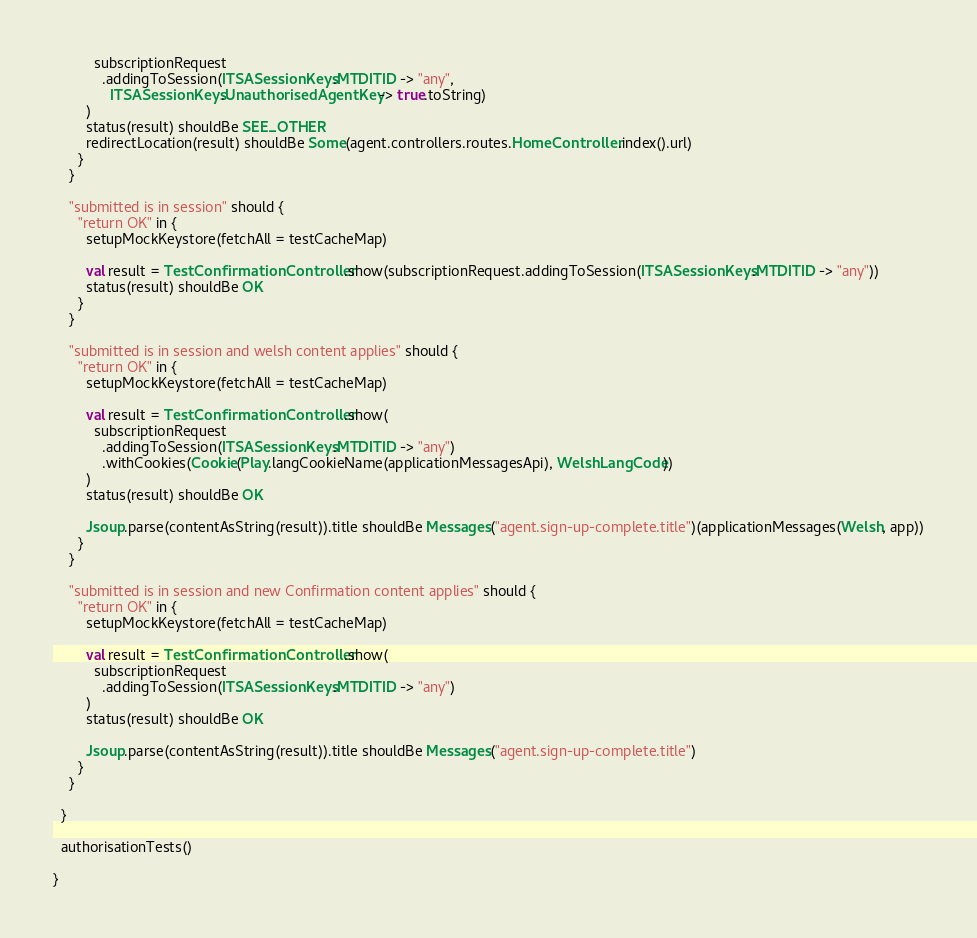<code> <loc_0><loc_0><loc_500><loc_500><_Scala_>          subscriptionRequest
            .addingToSession(ITSASessionKeys.MTDITID -> "any",
              ITSASessionKeys.UnauthorisedAgentKey -> true.toString)
        )
        status(result) shouldBe SEE_OTHER
        redirectLocation(result) shouldBe Some(agent.controllers.routes.HomeController.index().url)
      }
    }

    "submitted is in session" should {
      "return OK" in {
        setupMockKeystore(fetchAll = testCacheMap)

        val result = TestConfirmationController.show(subscriptionRequest.addingToSession(ITSASessionKeys.MTDITID -> "any"))
        status(result) shouldBe OK
      }
    }

    "submitted is in session and welsh content applies" should {
      "return OK" in {
        setupMockKeystore(fetchAll = testCacheMap)

        val result = TestConfirmationController.show(
          subscriptionRequest
            .addingToSession(ITSASessionKeys.MTDITID -> "any")
            .withCookies(Cookie(Play.langCookieName(applicationMessagesApi), WelshLangCode))
        )
        status(result) shouldBe OK

        Jsoup.parse(contentAsString(result)).title shouldBe Messages("agent.sign-up-complete.title")(applicationMessages(Welsh, app))
      }
    }

    "submitted is in session and new Confirmation content applies" should {
      "return OK" in {
        setupMockKeystore(fetchAll = testCacheMap)

        val result = TestConfirmationController.show(
          subscriptionRequest
            .addingToSession(ITSASessionKeys.MTDITID -> "any")
        )
        status(result) shouldBe OK

        Jsoup.parse(contentAsString(result)).title shouldBe Messages("agent.sign-up-complete.title")
      }
    }

  }

  authorisationTests()

}
</code> 